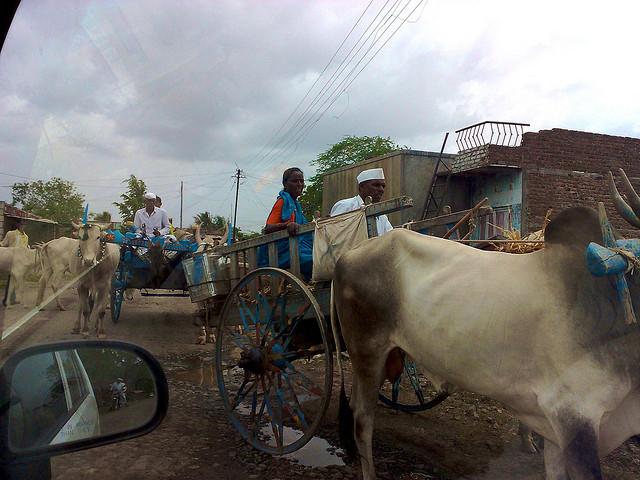What color is the animal?
Give a very brief answer. Tan. How many people are in this picture?
Keep it brief. 3. What kind of animal are they riding?
Give a very brief answer. Ox. How many wheels are on the cart on the left?
Quick response, please. 2. Where are the animals walking?
Short answer required. Road. 